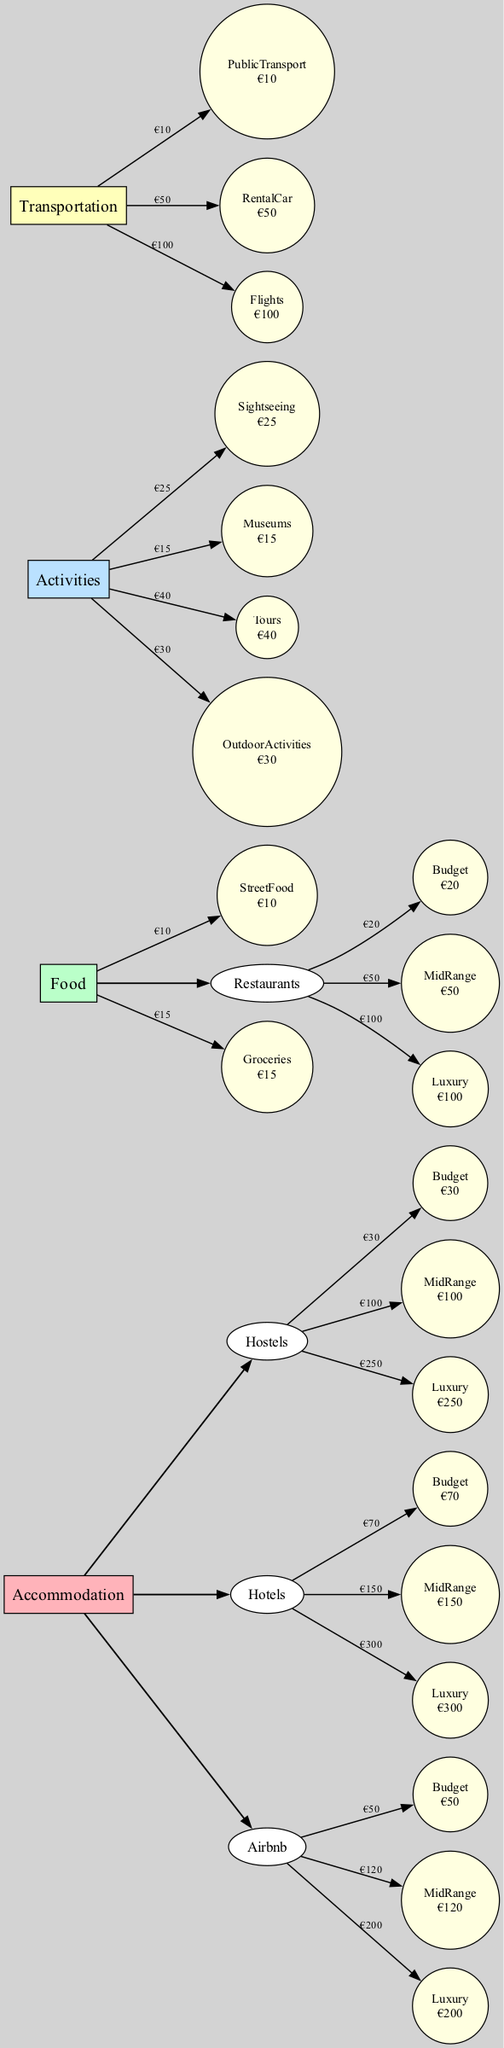What is the cost of Budget accommodation at Hostels? The diagram shows a specific node for Hostels under the Accommodation category with further breakdown into Budget types. The cost for the Budget accommodation at Hostels is listed as €30.
Answer: €30 How much does MidRange Food cost? In the Food category, there is a subcategory for Restaurants that has a MidRange option. The diagram indicates that the cost for MidRange Food at Restaurants is €50.
Answer: €50 Which category has the highest individual activity cost? The Activities category contains various costs for different activities, including Tours (€40) and Outdoor Activities (€30). Among these, the Tours cost is the highest, specifically labeled in the diagram.
Answer: Tours What’s the total cost for Luxury accommodations? To find the total cost for Luxury accommodations, we need to sum the Luxury costs across the three subcategories (Hostels, Hotels, Airbnb). These are €250 (Hostels), €300 (Hotels), and €200 (Airbnb). The total is €250 + €300 + €200 = €750.
Answer: €750 Which mode of Transportation is cheapest? The Transportation category lists three modes: Public Transport (€10), Rental Car (€50), and Flights (€100). Among these, Public Transport has the lowest cost, clearly indicated in the diagram.
Answer: Public Transport How many activities are listed under Activities? The Activities category includes four specific activities: Sightseeing, Museums, Tours, and Outdoor Activities. The diagram visually represents these, allowing us to count a total of four activities.
Answer: 4 What is the difference in cost between Luxury and Budget accommodations? To determine the difference in cost, we examine both Luxury and Budget accommodation options across Hostels, Hotels, and Airbnb categories. The highest Luxury accommodation cost is €300 (Hotels), and Budget is €70 (Hotels). The difference is €300 - €70 = €230.
Answer: €230 Which subcategory under Food has the least expensive option? Looking at the Food category, the least expensive option is Street Food, which costs €10. This is corroborated in the diagram where Street Food is shown separately with its cost.
Answer: Street Food What is the total budget for Transportation options listed? To find the total budget for the Transportation options, we add the costs of Public Transport (€10), Rental Car (€50), and Flights (€100) as shown in the diagram. The total is €10 + €50 + €100 = €160.
Answer: €160 